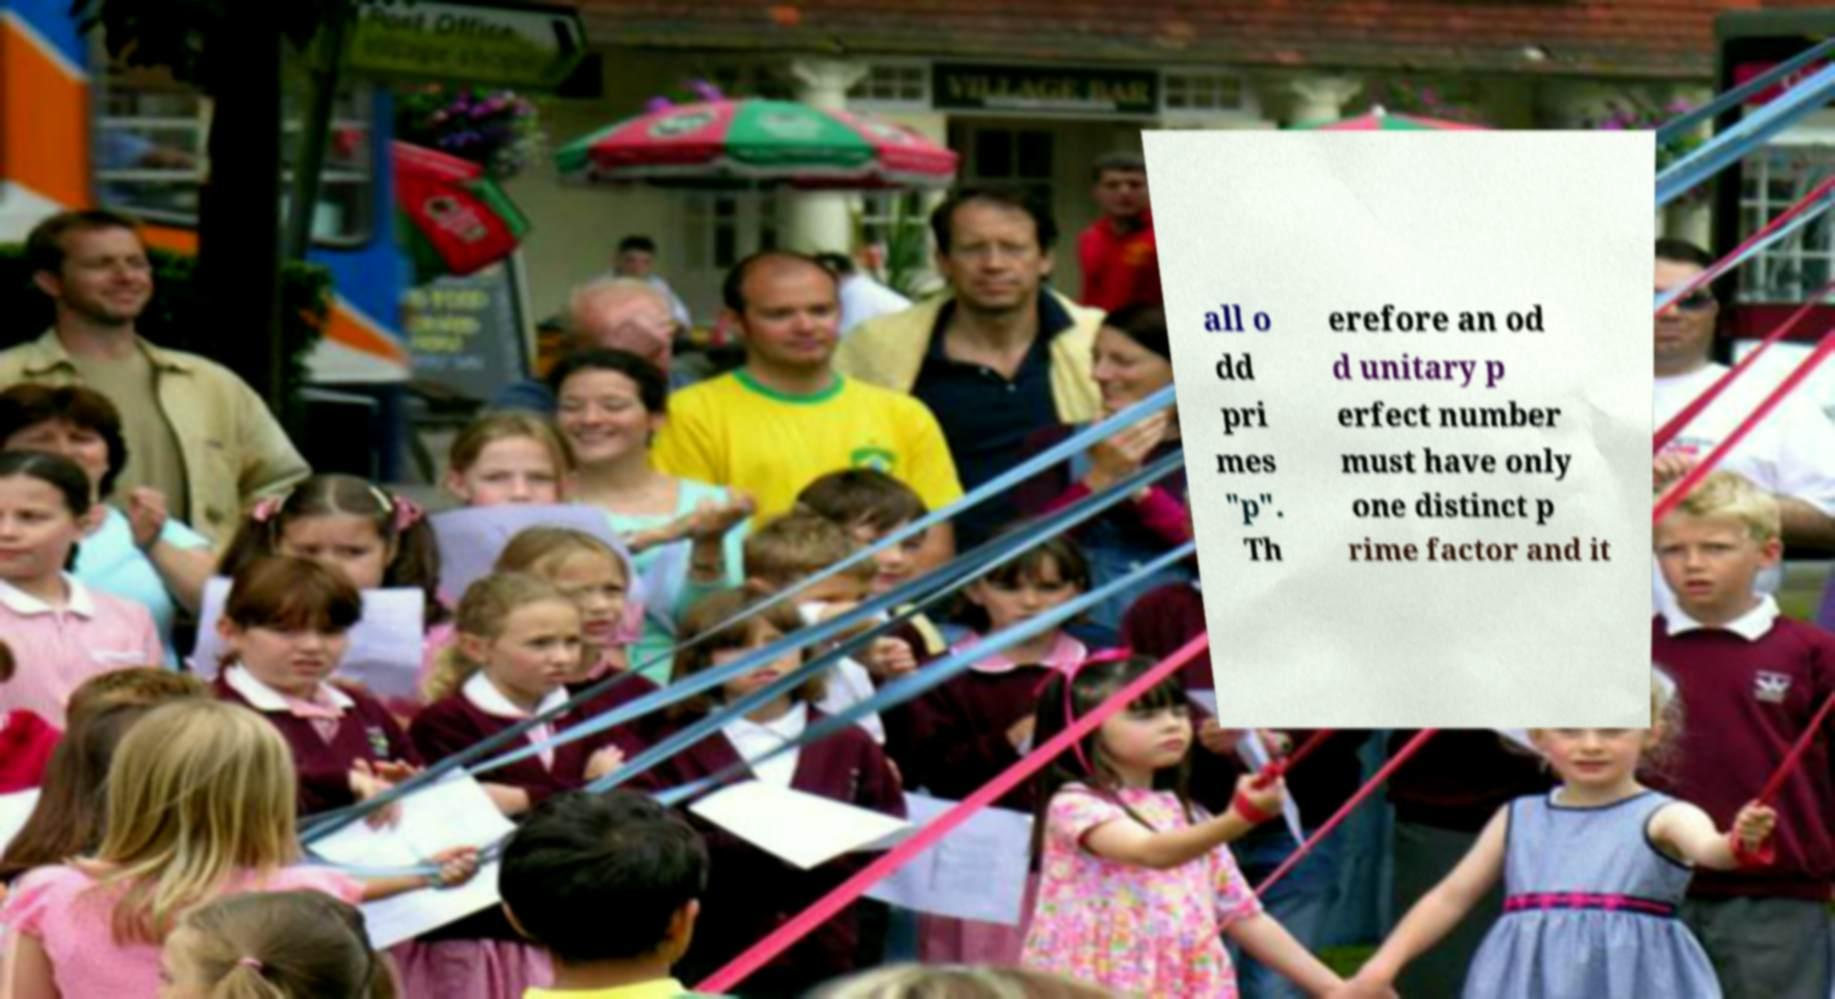Can you read and provide the text displayed in the image?This photo seems to have some interesting text. Can you extract and type it out for me? all o dd pri mes "p". Th erefore an od d unitary p erfect number must have only one distinct p rime factor and it 